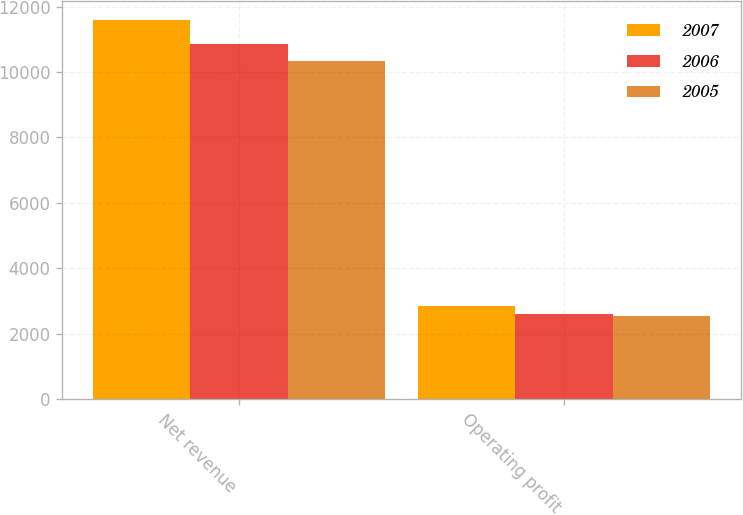Convert chart. <chart><loc_0><loc_0><loc_500><loc_500><stacked_bar_chart><ecel><fcel>Net revenue<fcel>Operating profit<nl><fcel>2007<fcel>11586<fcel>2845<nl><fcel>2006<fcel>10844<fcel>2615<nl><fcel>2005<fcel>10322<fcel>2529<nl></chart> 